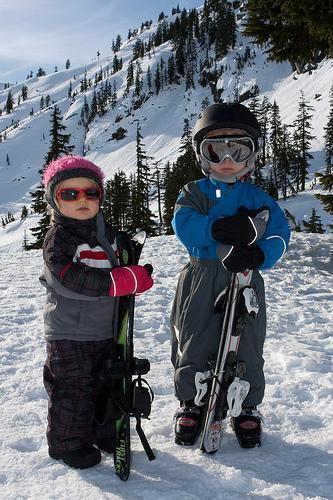How many people are pictured?
Give a very brief answer. 2. 